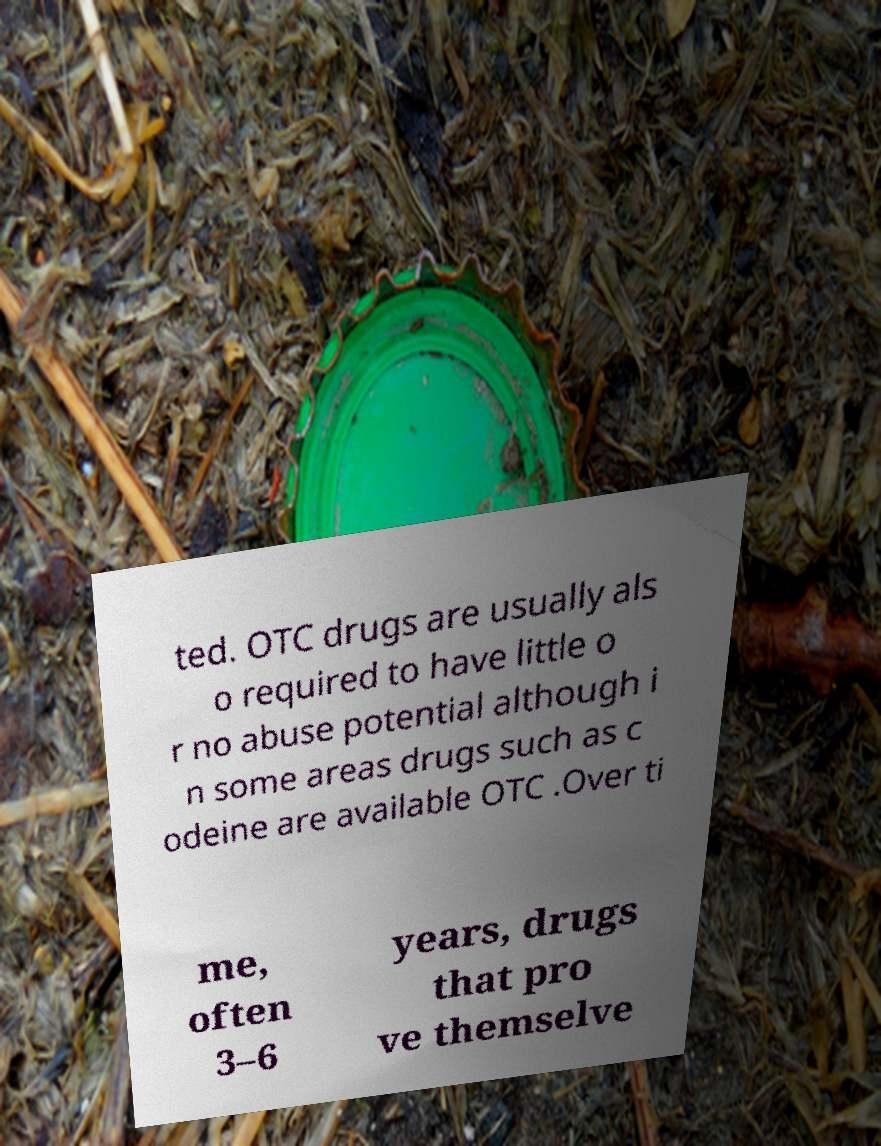Please read and relay the text visible in this image. What does it say? ted. OTC drugs are usually als o required to have little o r no abuse potential although i n some areas drugs such as c odeine are available OTC .Over ti me, often 3–6 years, drugs that pro ve themselve 